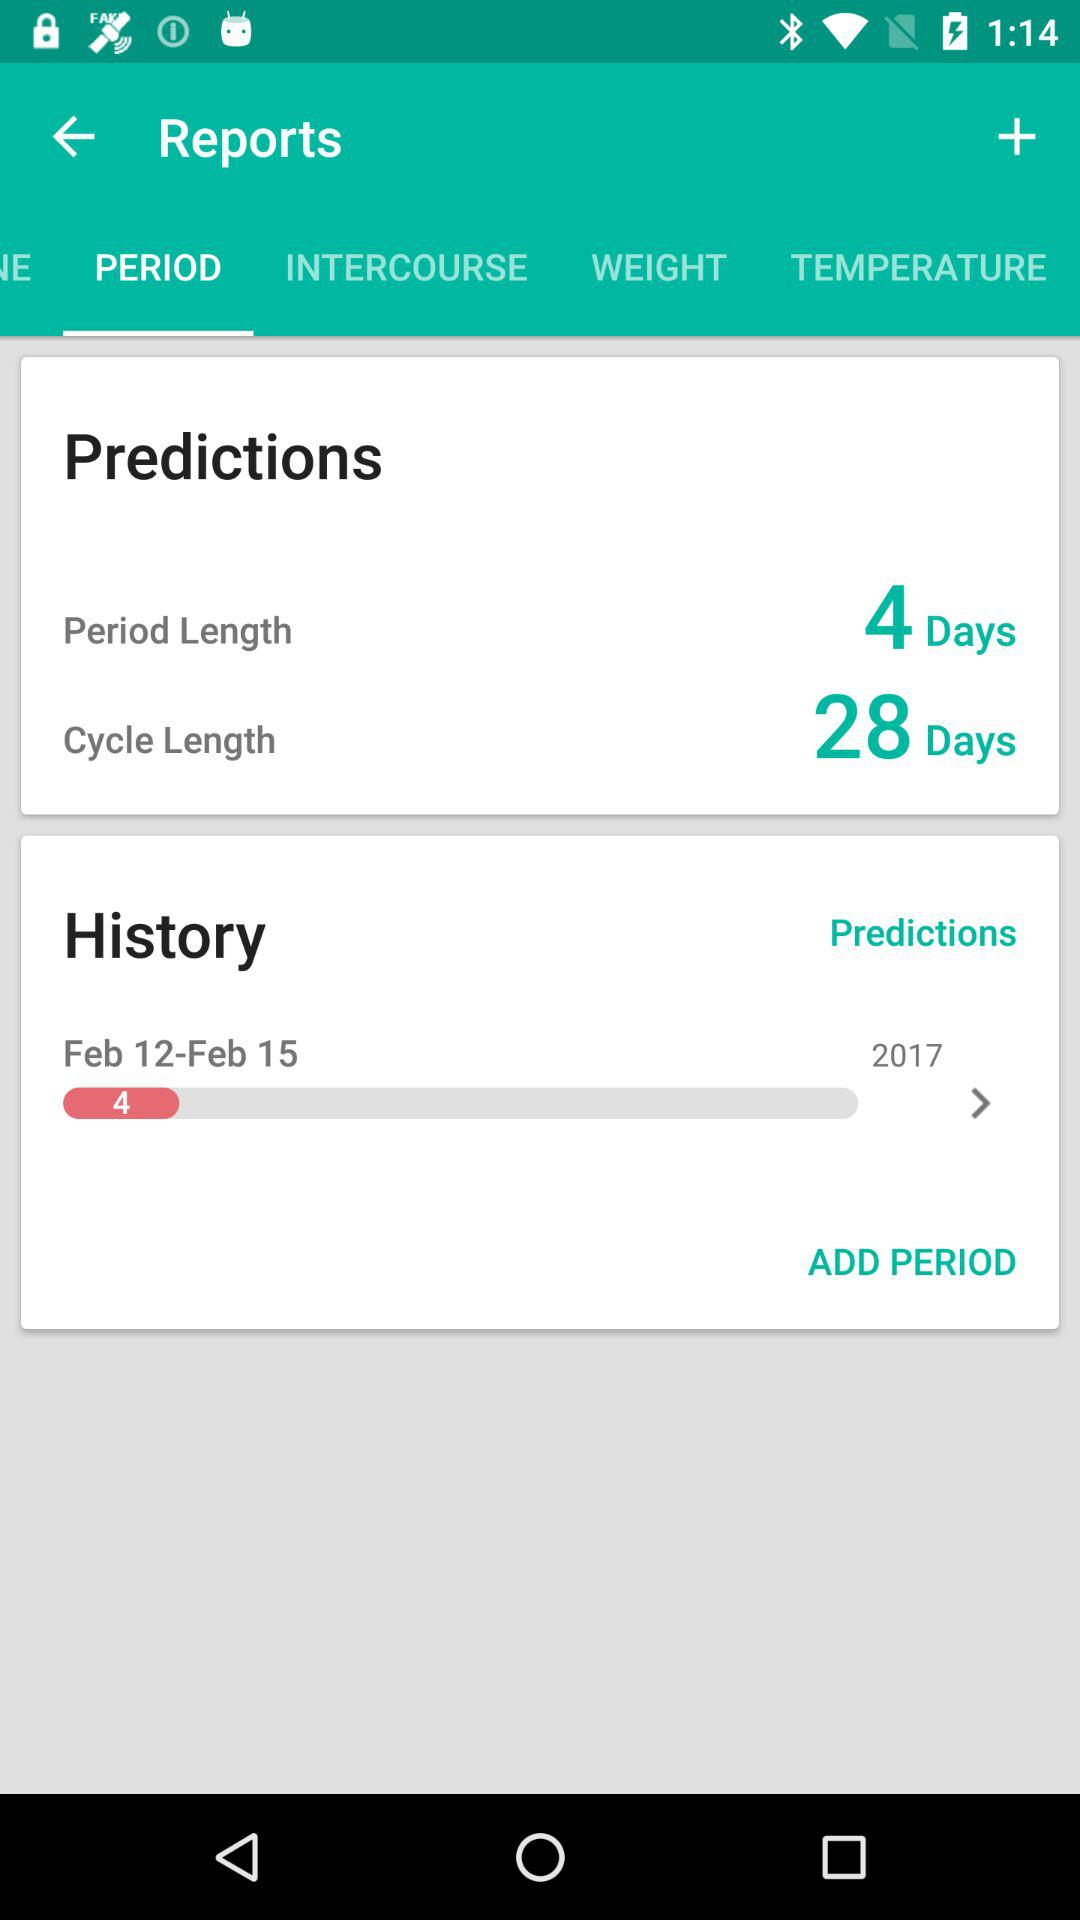How many days are there in the average cycle?
Answer the question using a single word or phrase. 28 